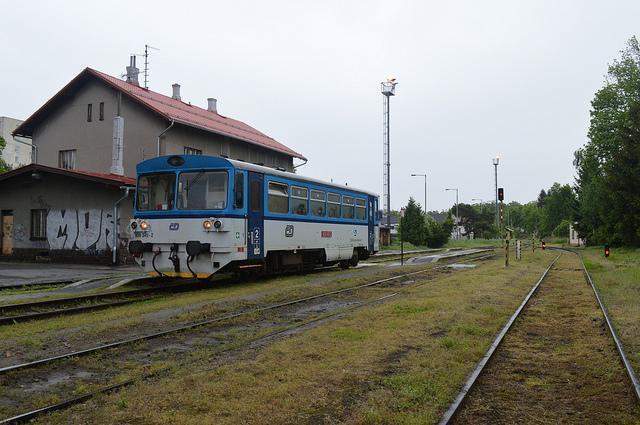How many cars does this train have?
Give a very brief answer. 1. 